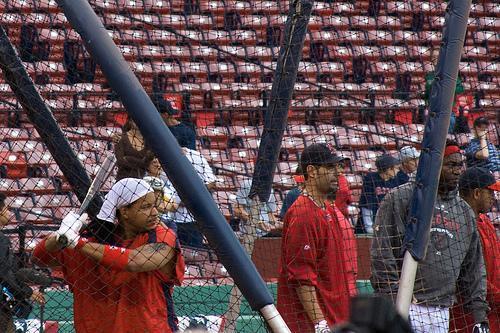How many people are wearing a red shirt?
Give a very brief answer. 3. 